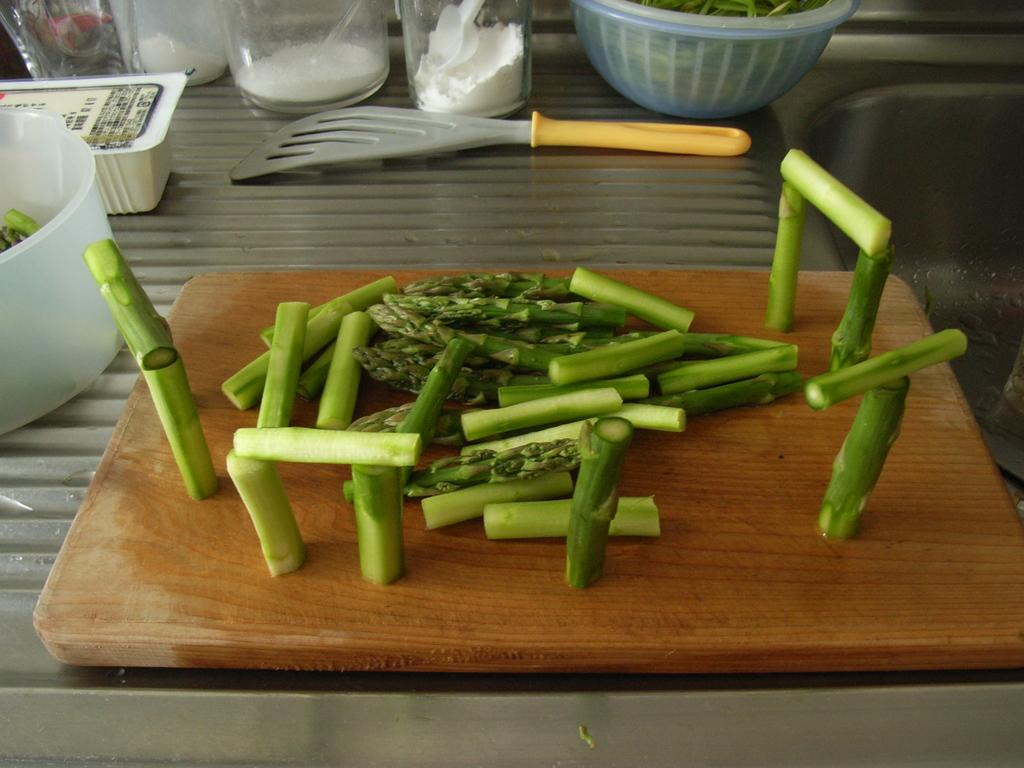What type of food items can be seen in the image? There are chopped vegetables in the image. On what surface are the chopped vegetables placed? The chopped vegetables are on a chopping pad. What other items can be seen in the image besides the chopped vegetables? There are bottles and bowls in the image. Where are the bottles and bowls located? The bottles and bowls are on a steel surface. What type of cable can be seen connecting the vegetables to the nest in the image? There is no cable or nest present in the image; it only features chopped vegetables, a chopping pad, bottles, and bowls on a steel surface. 